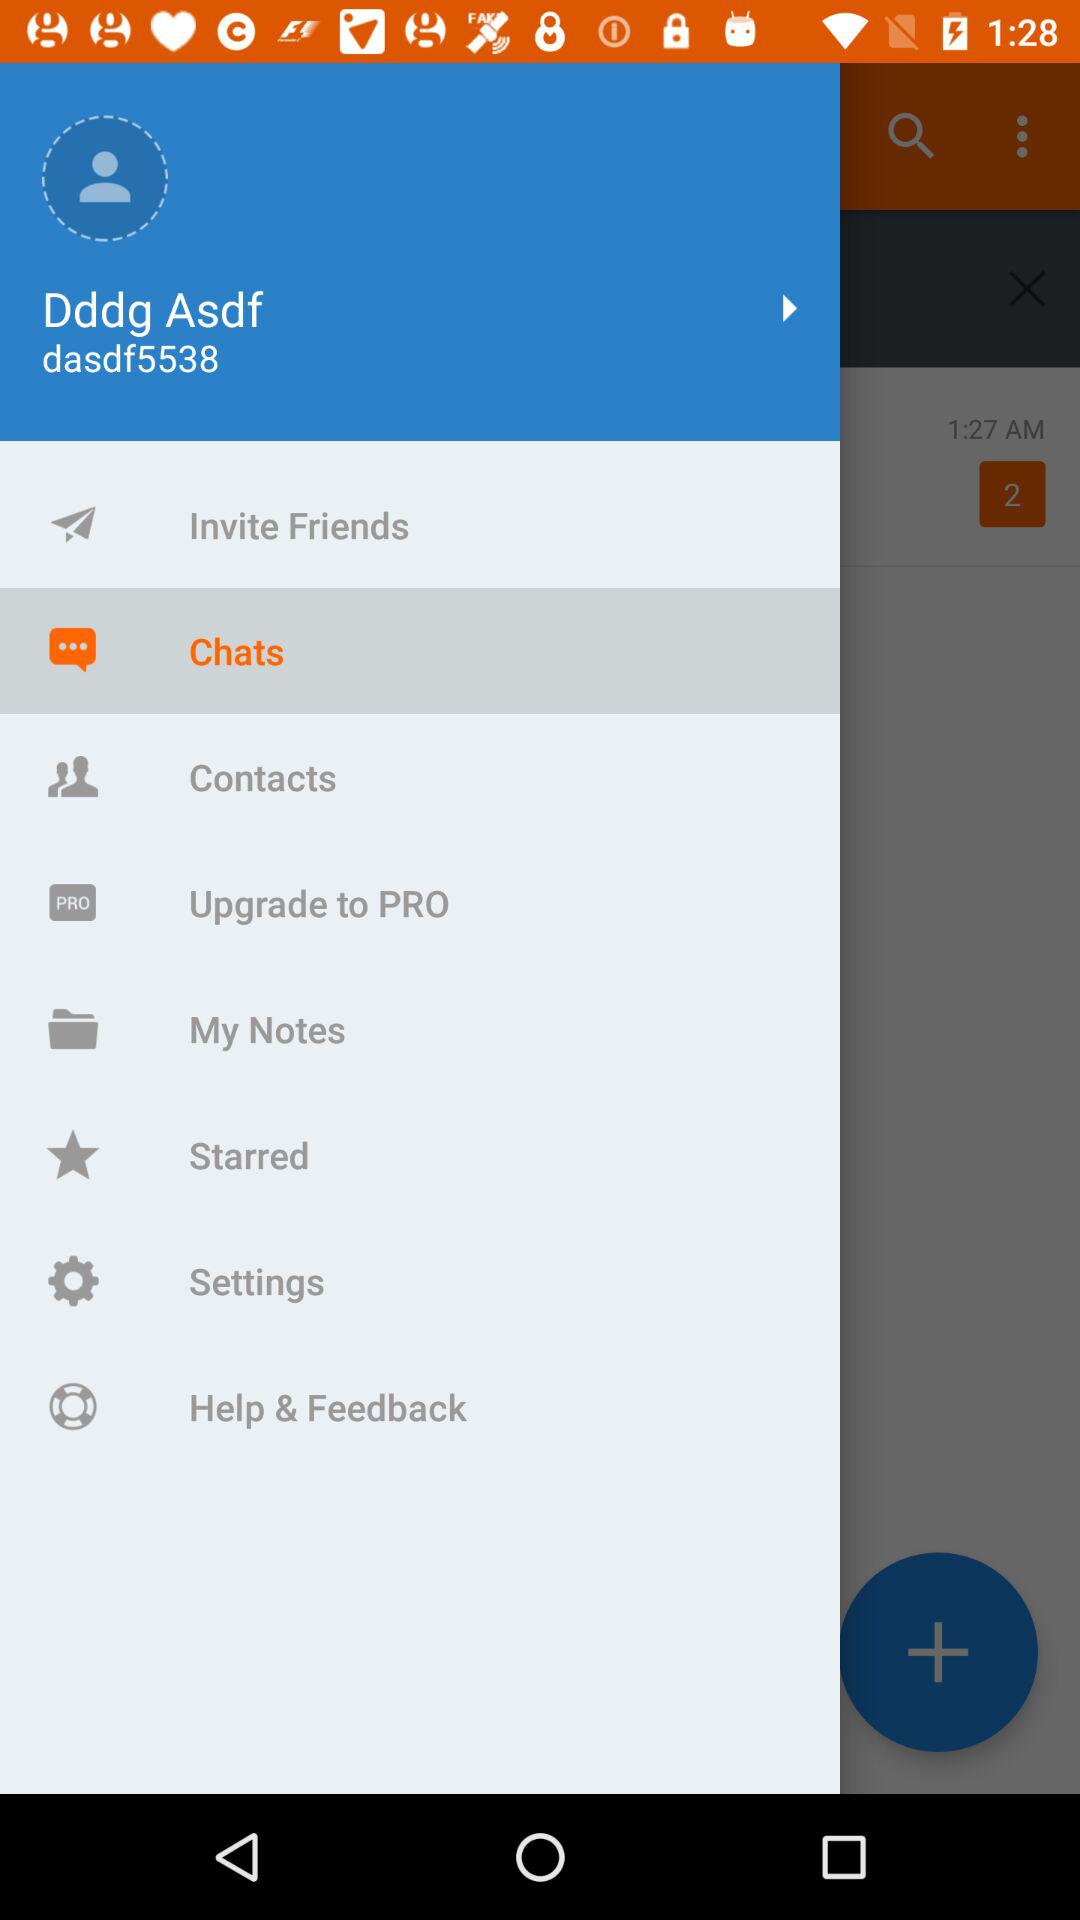What is the user's name? The user's name is Dddg Asdf. 